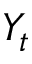<formula> <loc_0><loc_0><loc_500><loc_500>Y _ { t }</formula> 